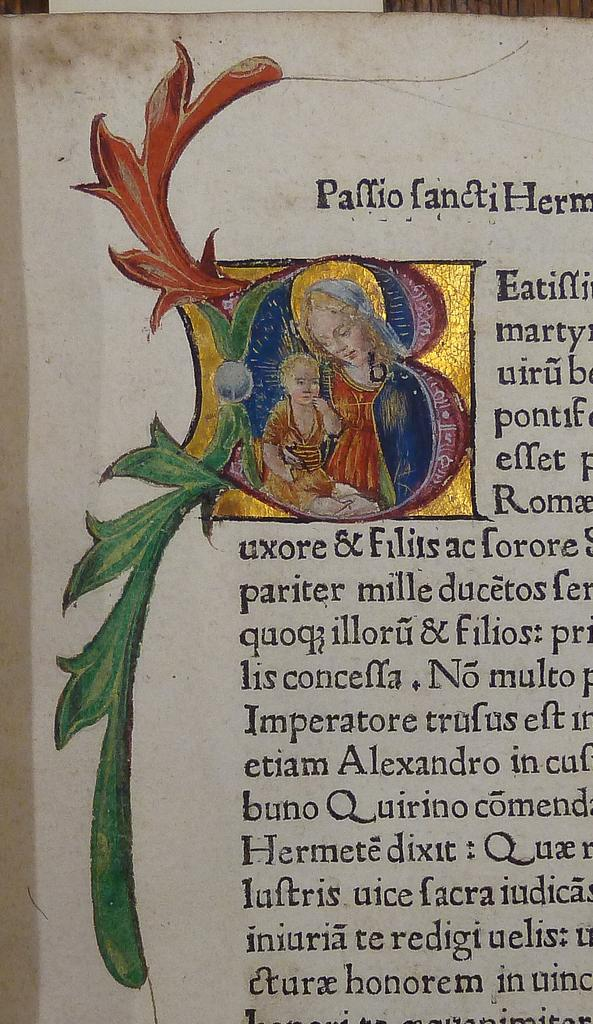What is the main subject of the painting in the image? The main subject of the painting in the image is a lady and a child. Where is the painting located in the image? The painting is in the center of the image. What else can be seen in the image besides the painting? There is text in the image. What type of breakfast is being served in the image? There is no breakfast visible in the image; it only contains a painting and text. What sense is being stimulated by the painting in the image? The painting in the image is visual, so it primarily stimulates the sense of sight. 